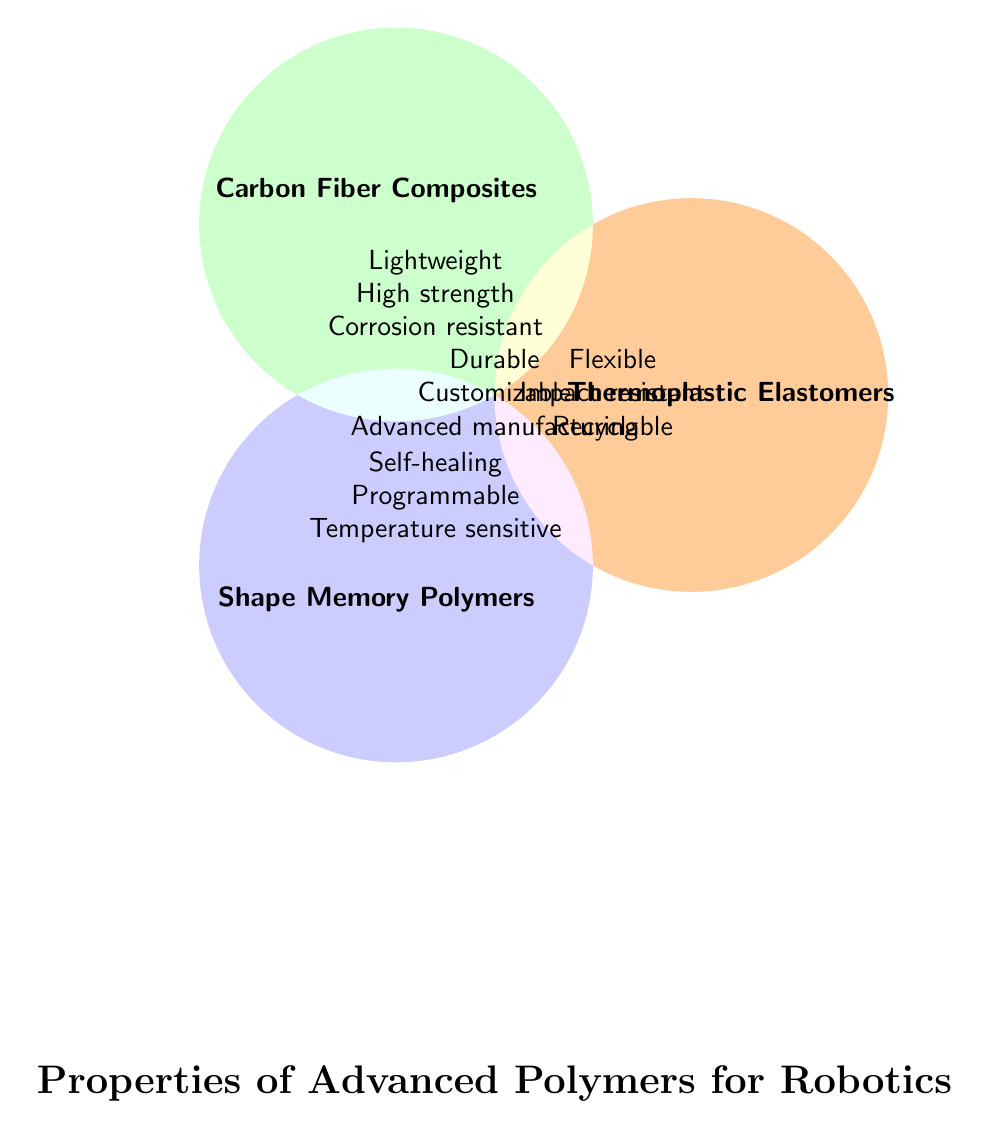What are the common properties of all advanced polymers for robotics? According to the center section of the Venn diagram where all three circles overlap, the common properties are listed as Durable, Customizable, and Advanced manufacturing.
Answer: Durable, Customizable, Advanced manufacturing Which category of advanced polymers has properties related to flexibility and recyclability? Looking at the diagram, the "Thermoplastic Elastomers" circle contains the properties Flexible, Impact resistant, and Recyclable.
Answer: Thermoplastic Elastomers How many properties are unique to Carbon Fiber Composites? The properties listed just in the Carbon Fiber Composites circle are Lightweight, High strength, and Corrosion resistant. Counting these gives three properties.
Answer: 3 Which material type includes self-healing as a property? The "Shape Memory Polymers" circle includes Self-healing along with another set of properties.
Answer: Shape Memory Polymers Are there materials that are both temperature sensitive and corrosion-resistant? Temperature sensitive is listed under Shape Memory Polymers and Corrosion resistant is under Carbon Fiber Composites. There is no overlap of these two properties within any of the circles.
Answer: No What is the intersection of properties between Thermoplastic Elastomers and Shape Memory Polymers? Thermoplastic Elastomers and Shape Memory Polymers do not overlap in the diagram, so there is no common subset of properties specifically listed for both categories.
Answer: None Which materials would be suitable if recyclability and high strength are required? Recyclable is a property of Thermoplastic Elastomers, and High strength is a property of Carbon Fiber Composites. No single material type represented in the diagram has both these properties.
Answer: None Which category of polymers has the most properties related to environmental sustainability? Recyclable and Corrosion resistant are environmentally relevant, belonging to Thermoplastic Elastomers and Carbon Fiber Composites respectively. Thermoplastic Elastomers also have three properties listed, while Carbon Fiber Composites have three as well. However, overall environmental sustainability factors such as durability and recyclability point towards Thermoplastic Elastomers.
Answer: Thermoplastic Elastomers What properties does the category shared by all materials have? The central overlap of all categories lists Durable, Customizable, and Advanced manufacturing as shared properties.
Answer: Durable, Customizable, Advanced manufacturing Which set of properties is unique to shape memory polymers but not shared with any other polymer listed? Unique properties in the Shape Memory Polymers circle are Self-healing, Programmable, and Temperature sensitive as seen in the separate section of the shape memory section.
Answer: Self-healing, Programmable, Temperature sensitive 